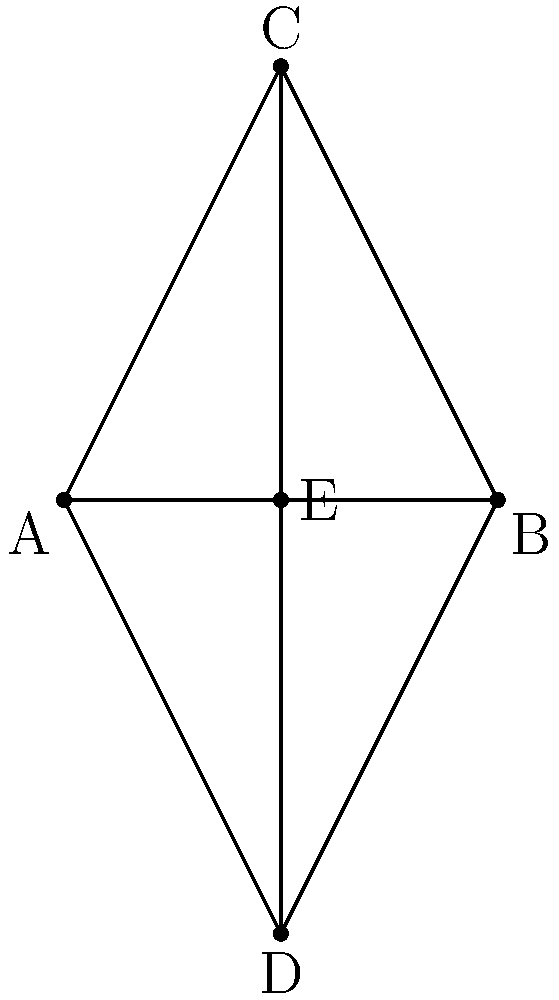In the cross symbol ACBD, point E is the midpoint of AB. If AC = 5 units and AE = 1 unit, what is the length of CD? Let's approach this step-by-step:

1) First, we need to recognize that triangles ACE and CDE are similar. This is because:
   - Angle ACE = Angle DCE (vertically opposite angles)
   - Angle AEC = Angle CED (alternate angles, as CE is parallel to AB)
   - Angle CAE = Angle CDE (both are right angles in a cross symbol)

2) In similar triangles, the ratio of corresponding sides is constant. Let's call this ratio r. We can find r using the given information:

   $r = \frac{AC}{CE} = \frac{AE}{ED}$

3) We know that AC = 5 and AE = 1. Since E is the midpoint of AB, BE must also equal 1.

4) Using the Pythagorean theorem in triangle ACE:

   $CE^2 = AC^2 - AE^2 = 5^2 - 1^2 = 24$
   $CE = \sqrt{24} = 2\sqrt{6}$

5) Now we can calculate the ratio r:

   $r = \frac{AC}{CE} = \frac{5}{2\sqrt{6}}$

6) Since triangles ACE and CDE are similar with this ratio, we can say:

   $\frac{CD}{AC} = \frac{CE}{AC} = \frac{1}{r} = \frac{2\sqrt{6}}{5}$

7) Therefore:

   $CD = AC \cdot \frac{2\sqrt{6}}{5} = 5 \cdot \frac{2\sqrt{6}}{5} = 2\sqrt{6}$

Thus, the length of CD is $2\sqrt{6}$ units.
Answer: $2\sqrt{6}$ units 